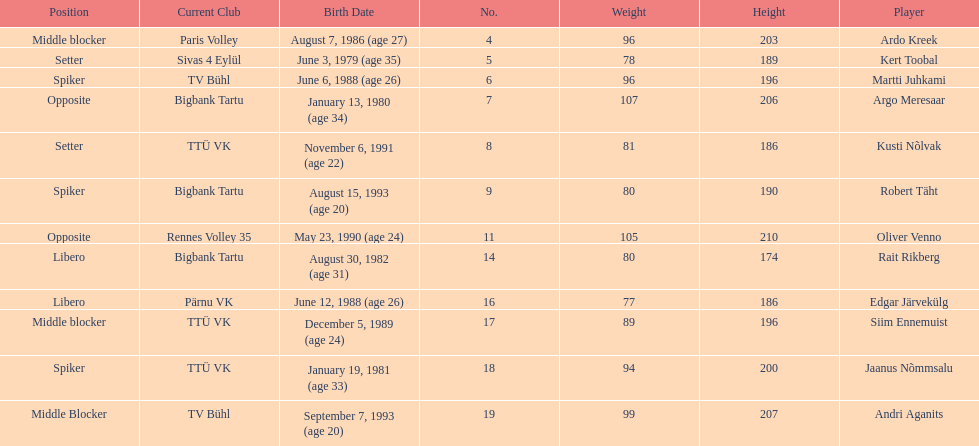How many members of estonia's men's national volleyball team were born in 1988? 2. 